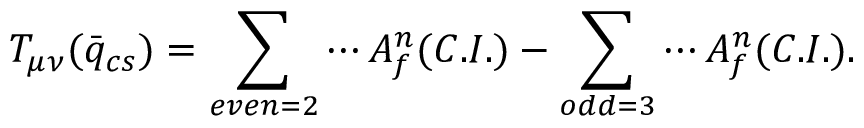<formula> <loc_0><loc_0><loc_500><loc_500>T _ { \mu \nu } ( \bar { q } _ { c s } ) = \sum _ { e v e n = 2 } \cdots A _ { f } ^ { n } ( C . I . ) - \sum _ { o d d = 3 } \cdots A _ { f } ^ { n } ( C . I . ) .</formula> 